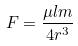<formula> <loc_0><loc_0><loc_500><loc_500>F = \frac { \mu l m } { 4 r ^ { 3 } }</formula> 